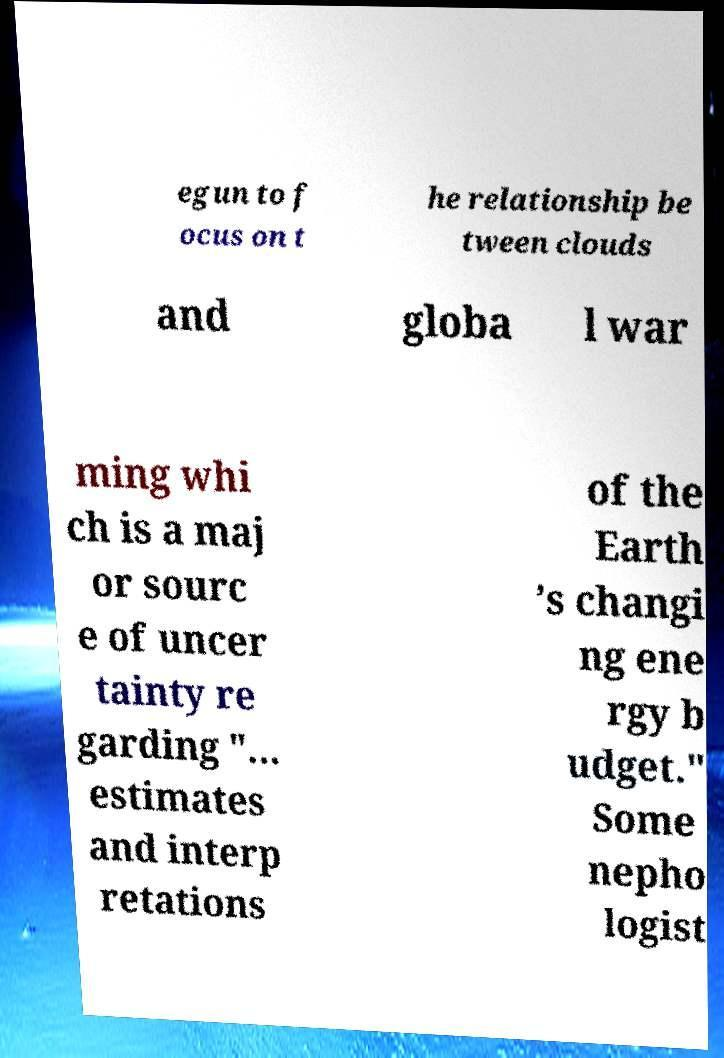I need the written content from this picture converted into text. Can you do that? egun to f ocus on t he relationship be tween clouds and globa l war ming whi ch is a maj or sourc e of uncer tainty re garding "... estimates and interp retations of the Earth ’s changi ng ene rgy b udget." Some nepho logist 